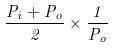Convert formula to latex. <formula><loc_0><loc_0><loc_500><loc_500>\frac { P _ { i } + P _ { o } } { 2 } \times \frac { 1 } { P _ { o } }</formula> 